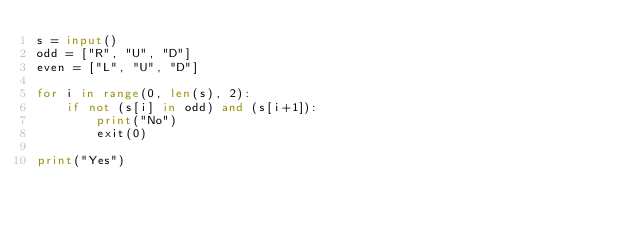Convert code to text. <code><loc_0><loc_0><loc_500><loc_500><_Python_>s = input()
odd = ["R", "U", "D"]
even = ["L", "U", "D"]

for i in range(0, len(s), 2):
    if not (s[i] in odd) and (s[i+1]):
        print("No")
        exit(0)

print("Yes")</code> 